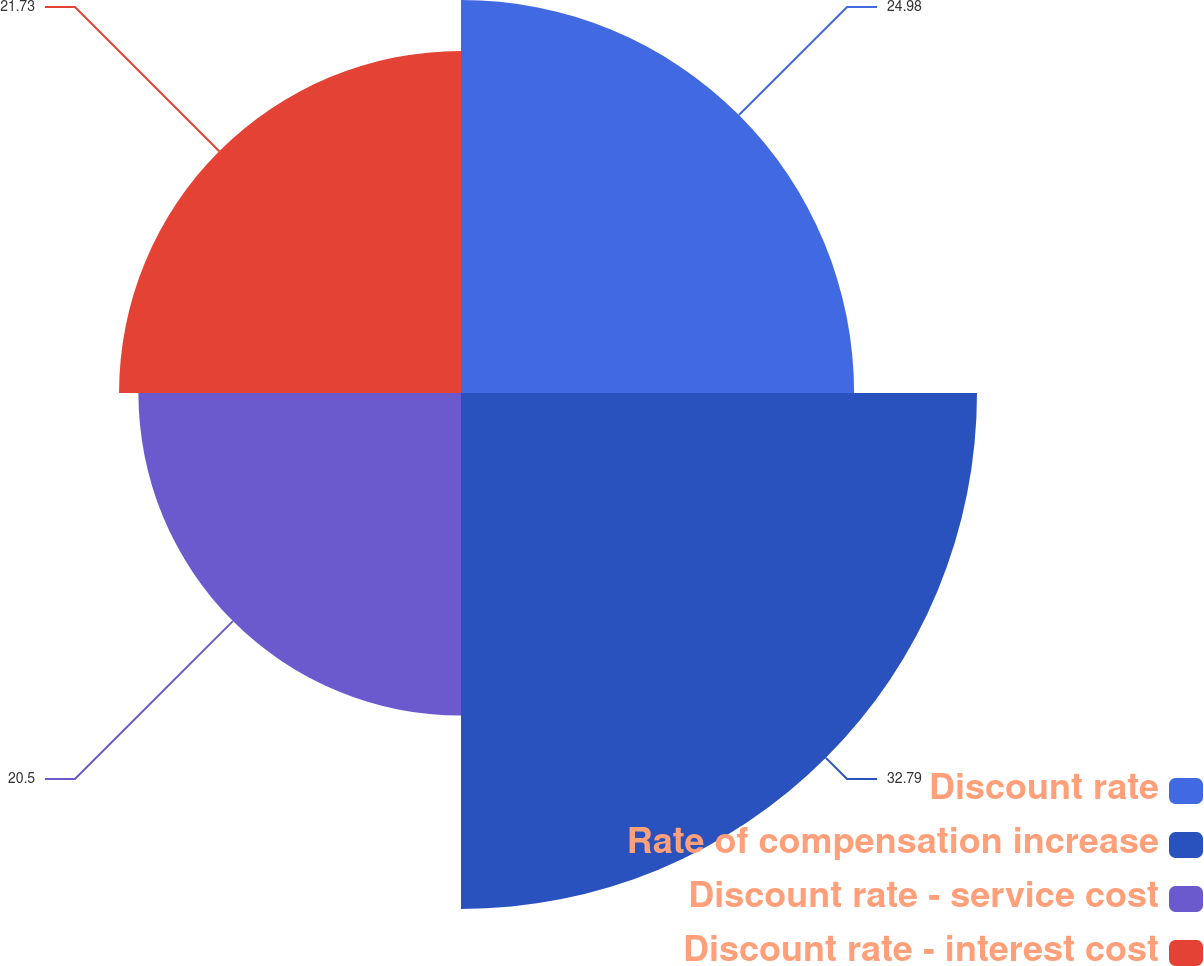Convert chart. <chart><loc_0><loc_0><loc_500><loc_500><pie_chart><fcel>Discount rate<fcel>Rate of compensation increase<fcel>Discount rate - service cost<fcel>Discount rate - interest cost<nl><fcel>24.98%<fcel>32.79%<fcel>20.5%<fcel>21.73%<nl></chart> 